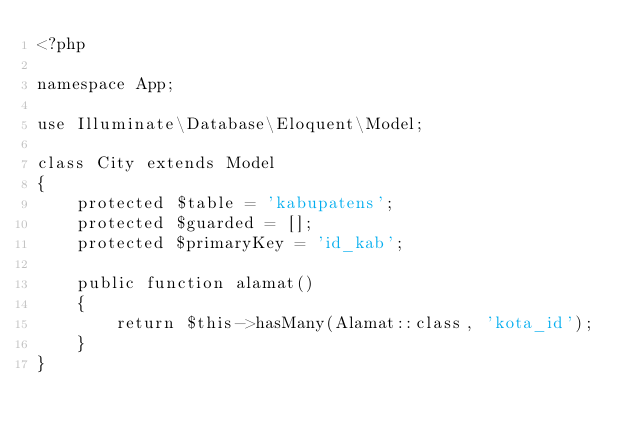<code> <loc_0><loc_0><loc_500><loc_500><_PHP_><?php

namespace App;

use Illuminate\Database\Eloquent\Model;

class City extends Model
{
    protected $table = 'kabupatens';
    protected $guarded = [];
    protected $primaryKey = 'id_kab';

    public function alamat()
    {
        return $this->hasMany(Alamat::class, 'kota_id');
    }
}
</code> 